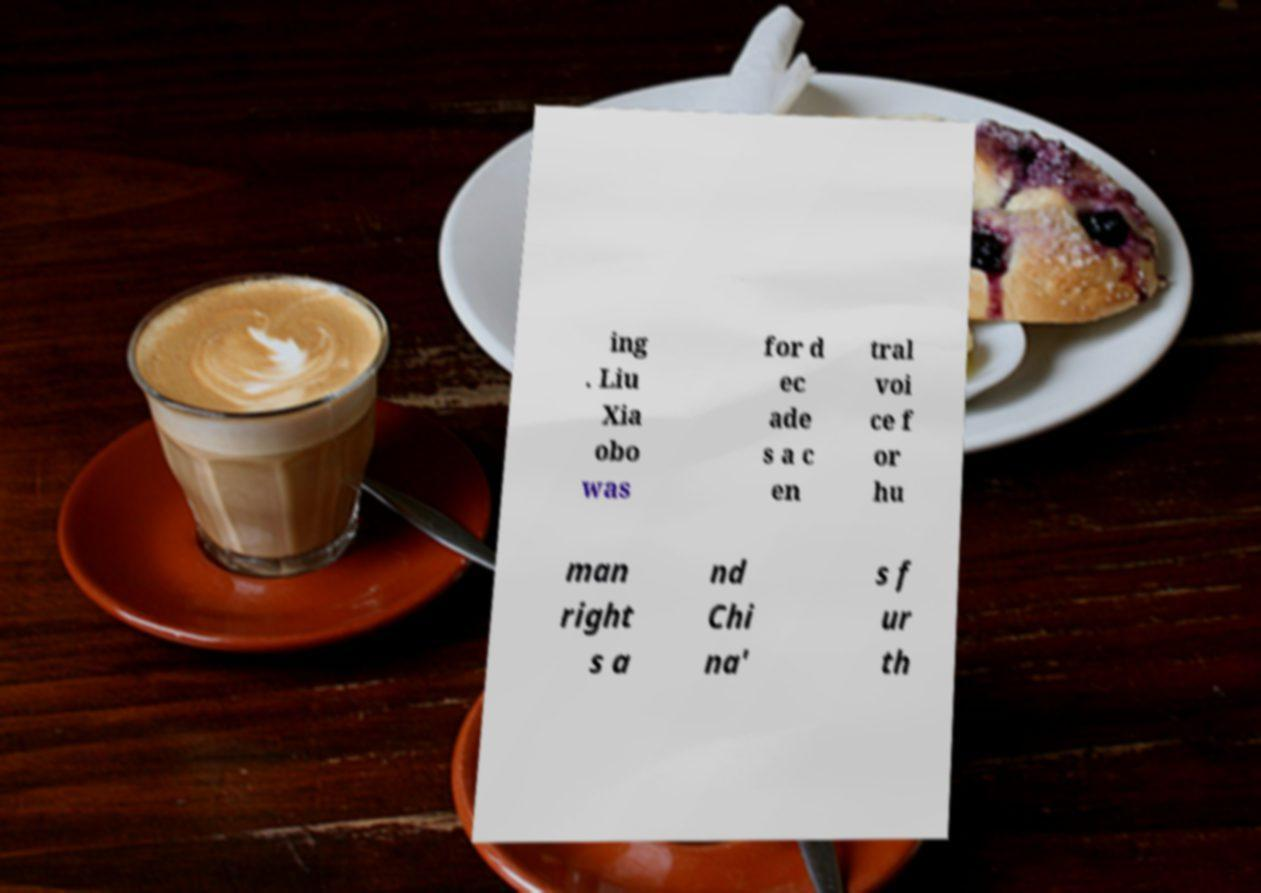Please read and relay the text visible in this image. What does it say? ing . Liu Xia obo was for d ec ade s a c en tral voi ce f or hu man right s a nd Chi na' s f ur th 